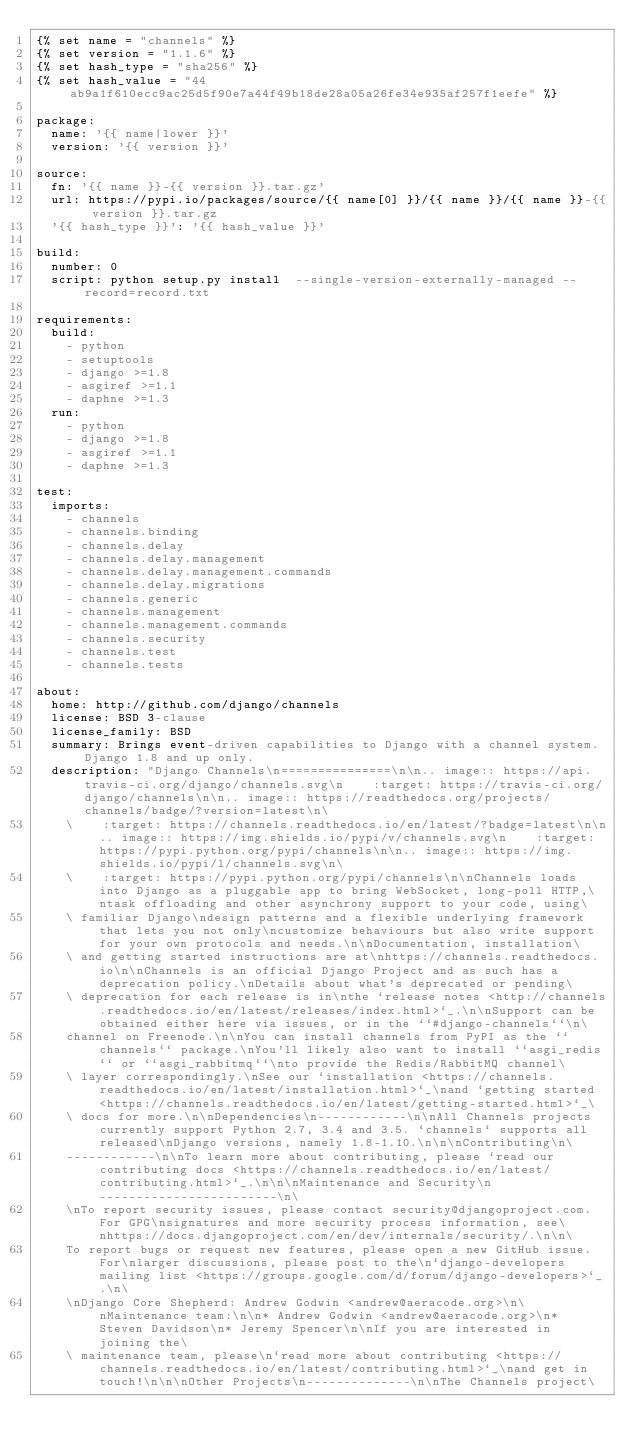<code> <loc_0><loc_0><loc_500><loc_500><_YAML_>{% set name = "channels" %}
{% set version = "1.1.6" %}
{% set hash_type = "sha256" %}
{% set hash_value = "44ab9a1f610ecc9ac25d5f90e7a44f49b18de28a05a26fe34e935af257f1eefe" %}

package:
  name: '{{ name|lower }}'
  version: '{{ version }}'

source:
  fn: '{{ name }}-{{ version }}.tar.gz'
  url: https://pypi.io/packages/source/{{ name[0] }}/{{ name }}/{{ name }}-{{ version }}.tar.gz
  '{{ hash_type }}': '{{ hash_value }}'

build:
  number: 0
  script: python setup.py install  --single-version-externally-managed --record=record.txt

requirements:
  build:
    - python
    - setuptools
    - django >=1.8
    - asgiref >=1.1
    - daphne >=1.3
  run:
    - python
    - django >=1.8
    - asgiref >=1.1
    - daphne >=1.3

test:
  imports:
    - channels
    - channels.binding
    - channels.delay
    - channels.delay.management
    - channels.delay.management.commands
    - channels.delay.migrations
    - channels.generic
    - channels.management
    - channels.management.commands
    - channels.security
    - channels.test
    - channels.tests

about:
  home: http://github.com/django/channels
  license: BSD 3-clause 
  license_family: BSD
  summary: Brings event-driven capabilities to Django with a channel system. Django 1.8 and up only.
  description: "Django Channels\n===============\n\n.. image:: https://api.travis-ci.org/django/channels.svg\n    :target: https://travis-ci.org/django/channels\n\n.. image:: https://readthedocs.org/projects/channels/badge/?version=latest\n\
    \    :target: https://channels.readthedocs.io/en/latest/?badge=latest\n\n.. image:: https://img.shields.io/pypi/v/channels.svg\n    :target: https://pypi.python.org/pypi/channels\n\n.. image:: https://img.shields.io/pypi/l/channels.svg\n\
    \    :target: https://pypi.python.org/pypi/channels\n\nChannels loads into Django as a pluggable app to bring WebSocket, long-poll HTTP,\ntask offloading and other asynchrony support to your code, using\
    \ familiar Django\ndesign patterns and a flexible underlying framework that lets you not only\ncustomize behaviours but also write support for your own protocols and needs.\n\nDocumentation, installation\
    \ and getting started instructions are at\nhttps://channels.readthedocs.io\n\nChannels is an official Django Project and as such has a deprecation policy.\nDetails about what's deprecated or pending\
    \ deprecation for each release is in\nthe `release notes <http://channels.readthedocs.io/en/latest/releases/index.html>`_.\n\nSupport can be obtained either here via issues, or in the ``#django-channels``\n\
    channel on Freenode.\n\nYou can install channels from PyPI as the ``channels`` package.\nYou'll likely also want to install ``asgi_redis`` or ``asgi_rabbitmq``\nto provide the Redis/RabbitMQ channel\
    \ layer correspondingly.\nSee our `installation <https://channels.readthedocs.io/en/latest/installation.html>`_\nand `getting started <https://channels.readthedocs.io/en/latest/getting-started.html>`_\
    \ docs for more.\n\nDependencies\n------------\n\nAll Channels projects currently support Python 2.7, 3.4 and 3.5. `channels` supports all released\nDjango versions, namely 1.8-1.10.\n\n\nContributing\n\
    ------------\n\nTo learn more about contributing, please `read our contributing docs <https://channels.readthedocs.io/en/latest/contributing.html>`_.\n\n\nMaintenance and Security\n------------------------\n\
    \nTo report security issues, please contact security@djangoproject.com. For GPG\nsignatures and more security process information, see\nhttps://docs.djangoproject.com/en/dev/internals/security/.\n\n\
    To report bugs or request new features, please open a new GitHub issue. For\nlarger discussions, please post to the\n`django-developers mailing list <https://groups.google.com/d/forum/django-developers>`_.\n\
    \nDjango Core Shepherd: Andrew Godwin <andrew@aeracode.org>\n\nMaintenance team:\n\n* Andrew Godwin <andrew@aeracode.org>\n* Steven Davidson\n* Jeremy Spencer\n\nIf you are interested in joining the\
    \ maintenance team, please\n`read more about contributing <https://channels.readthedocs.io/en/latest/contributing.html>`_\nand get in touch!\n\n\nOther Projects\n--------------\n\nThe Channels project\</code> 